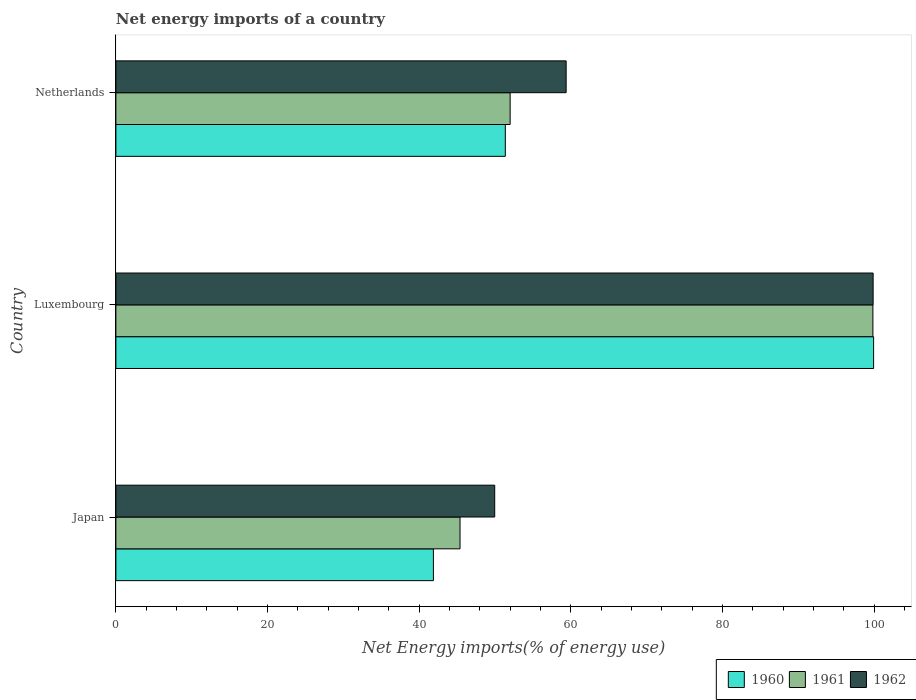How many bars are there on the 3rd tick from the top?
Provide a succinct answer. 3. How many bars are there on the 1st tick from the bottom?
Make the answer very short. 3. What is the label of the 3rd group of bars from the top?
Your answer should be very brief. Japan. In how many cases, is the number of bars for a given country not equal to the number of legend labels?
Your response must be concise. 0. What is the net energy imports in 1961 in Netherlands?
Give a very brief answer. 52. Across all countries, what is the maximum net energy imports in 1961?
Ensure brevity in your answer.  99.85. Across all countries, what is the minimum net energy imports in 1962?
Provide a short and direct response. 49.97. In which country was the net energy imports in 1962 maximum?
Make the answer very short. Luxembourg. What is the total net energy imports in 1961 in the graph?
Ensure brevity in your answer.  197.25. What is the difference between the net energy imports in 1960 in Luxembourg and that in Netherlands?
Your response must be concise. 48.58. What is the difference between the net energy imports in 1962 in Netherlands and the net energy imports in 1960 in Luxembourg?
Your response must be concise. -40.56. What is the average net energy imports in 1960 per country?
Your answer should be very brief. 64.4. What is the difference between the net energy imports in 1960 and net energy imports in 1962 in Netherlands?
Offer a very short reply. -8.02. In how many countries, is the net energy imports in 1960 greater than 52 %?
Provide a short and direct response. 1. What is the ratio of the net energy imports in 1961 in Luxembourg to that in Netherlands?
Your answer should be compact. 1.92. Is the net energy imports in 1962 in Luxembourg less than that in Netherlands?
Your answer should be very brief. No. What is the difference between the highest and the second highest net energy imports in 1962?
Offer a very short reply. 40.49. What is the difference between the highest and the lowest net energy imports in 1961?
Your response must be concise. 54.46. What does the 2nd bar from the top in Luxembourg represents?
Make the answer very short. 1961. What does the 2nd bar from the bottom in Luxembourg represents?
Ensure brevity in your answer.  1961. How many bars are there?
Your answer should be compact. 9. Are all the bars in the graph horizontal?
Provide a short and direct response. Yes. What is the difference between two consecutive major ticks on the X-axis?
Your answer should be very brief. 20. Where does the legend appear in the graph?
Your answer should be compact. Bottom right. What is the title of the graph?
Offer a very short reply. Net energy imports of a country. What is the label or title of the X-axis?
Your response must be concise. Net Energy imports(% of energy use). What is the Net Energy imports(% of energy use) of 1960 in Japan?
Provide a succinct answer. 41.88. What is the Net Energy imports(% of energy use) of 1961 in Japan?
Offer a very short reply. 45.39. What is the Net Energy imports(% of energy use) in 1962 in Japan?
Offer a very short reply. 49.97. What is the Net Energy imports(% of energy use) of 1960 in Luxembourg?
Ensure brevity in your answer.  99.95. What is the Net Energy imports(% of energy use) in 1961 in Luxembourg?
Ensure brevity in your answer.  99.85. What is the Net Energy imports(% of energy use) of 1962 in Luxembourg?
Keep it short and to the point. 99.88. What is the Net Energy imports(% of energy use) of 1960 in Netherlands?
Make the answer very short. 51.37. What is the Net Energy imports(% of energy use) of 1961 in Netherlands?
Offer a very short reply. 52. What is the Net Energy imports(% of energy use) of 1962 in Netherlands?
Provide a succinct answer. 59.39. Across all countries, what is the maximum Net Energy imports(% of energy use) in 1960?
Your response must be concise. 99.95. Across all countries, what is the maximum Net Energy imports(% of energy use) in 1961?
Your response must be concise. 99.85. Across all countries, what is the maximum Net Energy imports(% of energy use) of 1962?
Offer a terse response. 99.88. Across all countries, what is the minimum Net Energy imports(% of energy use) in 1960?
Offer a terse response. 41.88. Across all countries, what is the minimum Net Energy imports(% of energy use) in 1961?
Give a very brief answer. 45.39. Across all countries, what is the minimum Net Energy imports(% of energy use) of 1962?
Your answer should be very brief. 49.97. What is the total Net Energy imports(% of energy use) in 1960 in the graph?
Your response must be concise. 193.2. What is the total Net Energy imports(% of energy use) in 1961 in the graph?
Your answer should be compact. 197.25. What is the total Net Energy imports(% of energy use) in 1962 in the graph?
Offer a very short reply. 209.24. What is the difference between the Net Energy imports(% of energy use) of 1960 in Japan and that in Luxembourg?
Offer a very short reply. -58.07. What is the difference between the Net Energy imports(% of energy use) of 1961 in Japan and that in Luxembourg?
Your answer should be compact. -54.46. What is the difference between the Net Energy imports(% of energy use) of 1962 in Japan and that in Luxembourg?
Give a very brief answer. -49.92. What is the difference between the Net Energy imports(% of energy use) in 1960 in Japan and that in Netherlands?
Your response must be concise. -9.49. What is the difference between the Net Energy imports(% of energy use) in 1961 in Japan and that in Netherlands?
Offer a terse response. -6.61. What is the difference between the Net Energy imports(% of energy use) of 1962 in Japan and that in Netherlands?
Give a very brief answer. -9.42. What is the difference between the Net Energy imports(% of energy use) of 1960 in Luxembourg and that in Netherlands?
Ensure brevity in your answer.  48.58. What is the difference between the Net Energy imports(% of energy use) of 1961 in Luxembourg and that in Netherlands?
Make the answer very short. 47.85. What is the difference between the Net Energy imports(% of energy use) of 1962 in Luxembourg and that in Netherlands?
Keep it short and to the point. 40.49. What is the difference between the Net Energy imports(% of energy use) of 1960 in Japan and the Net Energy imports(% of energy use) of 1961 in Luxembourg?
Provide a succinct answer. -57.97. What is the difference between the Net Energy imports(% of energy use) in 1960 in Japan and the Net Energy imports(% of energy use) in 1962 in Luxembourg?
Give a very brief answer. -58. What is the difference between the Net Energy imports(% of energy use) of 1961 in Japan and the Net Energy imports(% of energy use) of 1962 in Luxembourg?
Offer a very short reply. -54.49. What is the difference between the Net Energy imports(% of energy use) of 1960 in Japan and the Net Energy imports(% of energy use) of 1961 in Netherlands?
Offer a very short reply. -10.12. What is the difference between the Net Energy imports(% of energy use) in 1960 in Japan and the Net Energy imports(% of energy use) in 1962 in Netherlands?
Your answer should be very brief. -17.51. What is the difference between the Net Energy imports(% of energy use) in 1961 in Japan and the Net Energy imports(% of energy use) in 1962 in Netherlands?
Keep it short and to the point. -14. What is the difference between the Net Energy imports(% of energy use) in 1960 in Luxembourg and the Net Energy imports(% of energy use) in 1961 in Netherlands?
Ensure brevity in your answer.  47.94. What is the difference between the Net Energy imports(% of energy use) of 1960 in Luxembourg and the Net Energy imports(% of energy use) of 1962 in Netherlands?
Offer a terse response. 40.56. What is the difference between the Net Energy imports(% of energy use) in 1961 in Luxembourg and the Net Energy imports(% of energy use) in 1962 in Netherlands?
Your answer should be compact. 40.46. What is the average Net Energy imports(% of energy use) of 1960 per country?
Provide a succinct answer. 64.4. What is the average Net Energy imports(% of energy use) of 1961 per country?
Provide a succinct answer. 65.75. What is the average Net Energy imports(% of energy use) of 1962 per country?
Your response must be concise. 69.75. What is the difference between the Net Energy imports(% of energy use) in 1960 and Net Energy imports(% of energy use) in 1961 in Japan?
Your response must be concise. -3.51. What is the difference between the Net Energy imports(% of energy use) of 1960 and Net Energy imports(% of energy use) of 1962 in Japan?
Keep it short and to the point. -8.09. What is the difference between the Net Energy imports(% of energy use) of 1961 and Net Energy imports(% of energy use) of 1962 in Japan?
Your answer should be very brief. -4.57. What is the difference between the Net Energy imports(% of energy use) in 1960 and Net Energy imports(% of energy use) in 1961 in Luxembourg?
Provide a short and direct response. 0.09. What is the difference between the Net Energy imports(% of energy use) of 1960 and Net Energy imports(% of energy use) of 1962 in Luxembourg?
Make the answer very short. 0.06. What is the difference between the Net Energy imports(% of energy use) in 1961 and Net Energy imports(% of energy use) in 1962 in Luxembourg?
Give a very brief answer. -0.03. What is the difference between the Net Energy imports(% of energy use) of 1960 and Net Energy imports(% of energy use) of 1961 in Netherlands?
Give a very brief answer. -0.64. What is the difference between the Net Energy imports(% of energy use) of 1960 and Net Energy imports(% of energy use) of 1962 in Netherlands?
Offer a terse response. -8.02. What is the difference between the Net Energy imports(% of energy use) of 1961 and Net Energy imports(% of energy use) of 1962 in Netherlands?
Give a very brief answer. -7.39. What is the ratio of the Net Energy imports(% of energy use) of 1960 in Japan to that in Luxembourg?
Give a very brief answer. 0.42. What is the ratio of the Net Energy imports(% of energy use) of 1961 in Japan to that in Luxembourg?
Give a very brief answer. 0.45. What is the ratio of the Net Energy imports(% of energy use) in 1962 in Japan to that in Luxembourg?
Ensure brevity in your answer.  0.5. What is the ratio of the Net Energy imports(% of energy use) of 1960 in Japan to that in Netherlands?
Your answer should be compact. 0.82. What is the ratio of the Net Energy imports(% of energy use) of 1961 in Japan to that in Netherlands?
Provide a succinct answer. 0.87. What is the ratio of the Net Energy imports(% of energy use) in 1962 in Japan to that in Netherlands?
Keep it short and to the point. 0.84. What is the ratio of the Net Energy imports(% of energy use) in 1960 in Luxembourg to that in Netherlands?
Keep it short and to the point. 1.95. What is the ratio of the Net Energy imports(% of energy use) in 1961 in Luxembourg to that in Netherlands?
Your answer should be compact. 1.92. What is the ratio of the Net Energy imports(% of energy use) of 1962 in Luxembourg to that in Netherlands?
Ensure brevity in your answer.  1.68. What is the difference between the highest and the second highest Net Energy imports(% of energy use) of 1960?
Your answer should be compact. 48.58. What is the difference between the highest and the second highest Net Energy imports(% of energy use) of 1961?
Make the answer very short. 47.85. What is the difference between the highest and the second highest Net Energy imports(% of energy use) in 1962?
Your answer should be very brief. 40.49. What is the difference between the highest and the lowest Net Energy imports(% of energy use) of 1960?
Your answer should be compact. 58.07. What is the difference between the highest and the lowest Net Energy imports(% of energy use) of 1961?
Provide a short and direct response. 54.46. What is the difference between the highest and the lowest Net Energy imports(% of energy use) in 1962?
Provide a succinct answer. 49.92. 